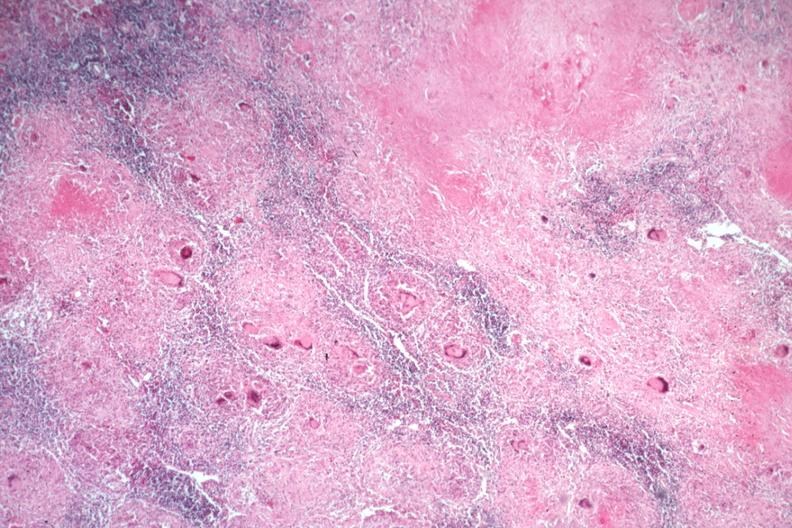what is present?
Answer the question using a single word or phrase. Lymph node 